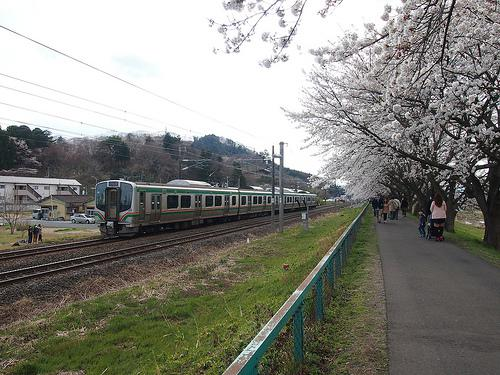Question: who is beside the train?
Choices:
A. Three people.
B. A dog.
C. An old man.
D. Five children.
Answer with the letter. Answer: A Question: where was the picture taken?
Choices:
A. At a picnic.
B. At the church.
C. At a park.
D. Near the school.
Answer with the letter. Answer: C Question: what is the make of the rail?
Choices:
A. Wood.
B. Metal.
C. Plastic.
D. Glass.
Answer with the letter. Answer: B 